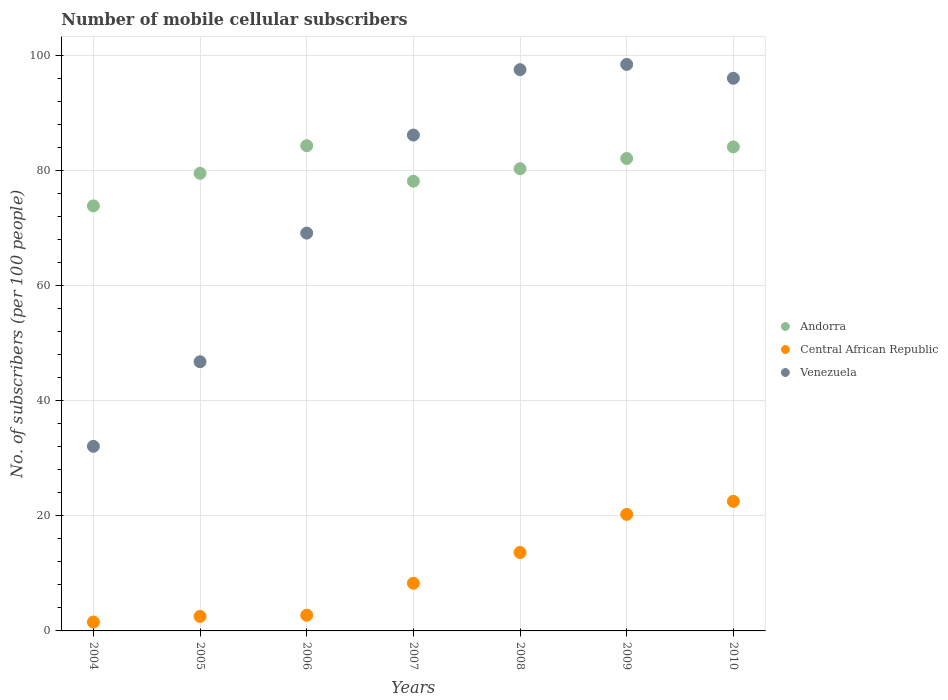How many different coloured dotlines are there?
Offer a very short reply. 3. Is the number of dotlines equal to the number of legend labels?
Your answer should be compact. Yes. What is the number of mobile cellular subscribers in Venezuela in 2010?
Provide a succinct answer. 96. Across all years, what is the maximum number of mobile cellular subscribers in Venezuela?
Make the answer very short. 98.39. Across all years, what is the minimum number of mobile cellular subscribers in Venezuela?
Ensure brevity in your answer.  32.07. In which year was the number of mobile cellular subscribers in Venezuela minimum?
Provide a short and direct response. 2004. What is the total number of mobile cellular subscribers in Central African Republic in the graph?
Make the answer very short. 71.45. What is the difference between the number of mobile cellular subscribers in Andorra in 2004 and that in 2010?
Provide a succinct answer. -10.24. What is the difference between the number of mobile cellular subscribers in Central African Republic in 2004 and the number of mobile cellular subscribers in Andorra in 2005?
Your answer should be very brief. -77.94. What is the average number of mobile cellular subscribers in Central African Republic per year?
Keep it short and to the point. 10.21. In the year 2007, what is the difference between the number of mobile cellular subscribers in Venezuela and number of mobile cellular subscribers in Central African Republic?
Your answer should be compact. 77.85. What is the ratio of the number of mobile cellular subscribers in Venezuela in 2005 to that in 2006?
Provide a succinct answer. 0.68. What is the difference between the highest and the second highest number of mobile cellular subscribers in Venezuela?
Keep it short and to the point. 0.9. What is the difference between the highest and the lowest number of mobile cellular subscribers in Andorra?
Offer a terse response. 10.45. Is it the case that in every year, the sum of the number of mobile cellular subscribers in Venezuela and number of mobile cellular subscribers in Central African Republic  is greater than the number of mobile cellular subscribers in Andorra?
Give a very brief answer. No. Does the number of mobile cellular subscribers in Venezuela monotonically increase over the years?
Offer a terse response. No. Is the number of mobile cellular subscribers in Central African Republic strictly greater than the number of mobile cellular subscribers in Venezuela over the years?
Offer a terse response. No. Is the number of mobile cellular subscribers in Central African Republic strictly less than the number of mobile cellular subscribers in Andorra over the years?
Make the answer very short. Yes. Are the values on the major ticks of Y-axis written in scientific E-notation?
Ensure brevity in your answer.  No. Does the graph contain any zero values?
Make the answer very short. No. Does the graph contain grids?
Offer a very short reply. Yes. Where does the legend appear in the graph?
Your response must be concise. Center right. How are the legend labels stacked?
Your answer should be compact. Vertical. What is the title of the graph?
Your response must be concise. Number of mobile cellular subscribers. Does "Romania" appear as one of the legend labels in the graph?
Give a very brief answer. No. What is the label or title of the Y-axis?
Keep it short and to the point. No. of subscribers (per 100 people). What is the No. of subscribers (per 100 people) of Andorra in 2004?
Your response must be concise. 73.82. What is the No. of subscribers (per 100 people) of Central African Republic in 2004?
Your answer should be very brief. 1.54. What is the No. of subscribers (per 100 people) in Venezuela in 2004?
Your answer should be compact. 32.07. What is the No. of subscribers (per 100 people) in Andorra in 2005?
Your answer should be compact. 79.48. What is the No. of subscribers (per 100 people) of Central African Republic in 2005?
Your response must be concise. 2.52. What is the No. of subscribers (per 100 people) of Venezuela in 2005?
Give a very brief answer. 46.76. What is the No. of subscribers (per 100 people) in Andorra in 2006?
Offer a terse response. 84.28. What is the No. of subscribers (per 100 people) in Central African Republic in 2006?
Offer a terse response. 2.73. What is the No. of subscribers (per 100 people) of Venezuela in 2006?
Keep it short and to the point. 69.1. What is the No. of subscribers (per 100 people) in Andorra in 2007?
Your answer should be compact. 78.12. What is the No. of subscribers (per 100 people) in Central African Republic in 2007?
Keep it short and to the point. 8.28. What is the No. of subscribers (per 100 people) of Venezuela in 2007?
Give a very brief answer. 86.13. What is the No. of subscribers (per 100 people) in Andorra in 2008?
Offer a terse response. 80.28. What is the No. of subscribers (per 100 people) in Central African Republic in 2008?
Your answer should be very brief. 13.62. What is the No. of subscribers (per 100 people) of Venezuela in 2008?
Offer a very short reply. 97.49. What is the No. of subscribers (per 100 people) in Andorra in 2009?
Make the answer very short. 82.06. What is the No. of subscribers (per 100 people) of Central African Republic in 2009?
Ensure brevity in your answer.  20.24. What is the No. of subscribers (per 100 people) of Venezuela in 2009?
Your answer should be very brief. 98.39. What is the No. of subscribers (per 100 people) in Andorra in 2010?
Offer a terse response. 84.07. What is the No. of subscribers (per 100 people) in Central African Republic in 2010?
Your response must be concise. 22.51. What is the No. of subscribers (per 100 people) of Venezuela in 2010?
Provide a succinct answer. 96. Across all years, what is the maximum No. of subscribers (per 100 people) of Andorra?
Ensure brevity in your answer.  84.28. Across all years, what is the maximum No. of subscribers (per 100 people) of Central African Republic?
Offer a terse response. 22.51. Across all years, what is the maximum No. of subscribers (per 100 people) of Venezuela?
Make the answer very short. 98.39. Across all years, what is the minimum No. of subscribers (per 100 people) of Andorra?
Your response must be concise. 73.82. Across all years, what is the minimum No. of subscribers (per 100 people) of Central African Republic?
Provide a short and direct response. 1.54. Across all years, what is the minimum No. of subscribers (per 100 people) in Venezuela?
Give a very brief answer. 32.07. What is the total No. of subscribers (per 100 people) in Andorra in the graph?
Your response must be concise. 562.12. What is the total No. of subscribers (per 100 people) of Central African Republic in the graph?
Your response must be concise. 71.45. What is the total No. of subscribers (per 100 people) in Venezuela in the graph?
Ensure brevity in your answer.  525.93. What is the difference between the No. of subscribers (per 100 people) of Andorra in 2004 and that in 2005?
Provide a succinct answer. -5.66. What is the difference between the No. of subscribers (per 100 people) in Central African Republic in 2004 and that in 2005?
Offer a terse response. -0.98. What is the difference between the No. of subscribers (per 100 people) in Venezuela in 2004 and that in 2005?
Offer a terse response. -14.69. What is the difference between the No. of subscribers (per 100 people) in Andorra in 2004 and that in 2006?
Provide a succinct answer. -10.45. What is the difference between the No. of subscribers (per 100 people) of Central African Republic in 2004 and that in 2006?
Offer a very short reply. -1.19. What is the difference between the No. of subscribers (per 100 people) in Venezuela in 2004 and that in 2006?
Offer a terse response. -37.04. What is the difference between the No. of subscribers (per 100 people) in Andorra in 2004 and that in 2007?
Provide a succinct answer. -4.29. What is the difference between the No. of subscribers (per 100 people) in Central African Republic in 2004 and that in 2007?
Keep it short and to the point. -6.74. What is the difference between the No. of subscribers (per 100 people) in Venezuela in 2004 and that in 2007?
Provide a short and direct response. -54.06. What is the difference between the No. of subscribers (per 100 people) of Andorra in 2004 and that in 2008?
Make the answer very short. -6.46. What is the difference between the No. of subscribers (per 100 people) of Central African Republic in 2004 and that in 2008?
Your answer should be compact. -12.08. What is the difference between the No. of subscribers (per 100 people) of Venezuela in 2004 and that in 2008?
Your response must be concise. -65.42. What is the difference between the No. of subscribers (per 100 people) of Andorra in 2004 and that in 2009?
Keep it short and to the point. -8.24. What is the difference between the No. of subscribers (per 100 people) of Central African Republic in 2004 and that in 2009?
Ensure brevity in your answer.  -18.7. What is the difference between the No. of subscribers (per 100 people) in Venezuela in 2004 and that in 2009?
Make the answer very short. -66.33. What is the difference between the No. of subscribers (per 100 people) of Andorra in 2004 and that in 2010?
Ensure brevity in your answer.  -10.24. What is the difference between the No. of subscribers (per 100 people) in Central African Republic in 2004 and that in 2010?
Provide a short and direct response. -20.97. What is the difference between the No. of subscribers (per 100 people) in Venezuela in 2004 and that in 2010?
Offer a terse response. -63.93. What is the difference between the No. of subscribers (per 100 people) in Andorra in 2005 and that in 2006?
Your response must be concise. -4.79. What is the difference between the No. of subscribers (per 100 people) of Central African Republic in 2005 and that in 2006?
Keep it short and to the point. -0.2. What is the difference between the No. of subscribers (per 100 people) of Venezuela in 2005 and that in 2006?
Give a very brief answer. -22.35. What is the difference between the No. of subscribers (per 100 people) in Andorra in 2005 and that in 2007?
Give a very brief answer. 1.37. What is the difference between the No. of subscribers (per 100 people) of Central African Republic in 2005 and that in 2007?
Provide a short and direct response. -5.75. What is the difference between the No. of subscribers (per 100 people) of Venezuela in 2005 and that in 2007?
Your answer should be very brief. -39.38. What is the difference between the No. of subscribers (per 100 people) in Andorra in 2005 and that in 2008?
Provide a short and direct response. -0.8. What is the difference between the No. of subscribers (per 100 people) of Central African Republic in 2005 and that in 2008?
Keep it short and to the point. -11.1. What is the difference between the No. of subscribers (per 100 people) of Venezuela in 2005 and that in 2008?
Your answer should be compact. -50.73. What is the difference between the No. of subscribers (per 100 people) in Andorra in 2005 and that in 2009?
Provide a succinct answer. -2.58. What is the difference between the No. of subscribers (per 100 people) in Central African Republic in 2005 and that in 2009?
Provide a short and direct response. -17.72. What is the difference between the No. of subscribers (per 100 people) in Venezuela in 2005 and that in 2009?
Make the answer very short. -51.64. What is the difference between the No. of subscribers (per 100 people) of Andorra in 2005 and that in 2010?
Keep it short and to the point. -4.58. What is the difference between the No. of subscribers (per 100 people) in Central African Republic in 2005 and that in 2010?
Your response must be concise. -19.99. What is the difference between the No. of subscribers (per 100 people) in Venezuela in 2005 and that in 2010?
Offer a very short reply. -49.24. What is the difference between the No. of subscribers (per 100 people) of Andorra in 2006 and that in 2007?
Your answer should be compact. 6.16. What is the difference between the No. of subscribers (per 100 people) of Central African Republic in 2006 and that in 2007?
Offer a very short reply. -5.55. What is the difference between the No. of subscribers (per 100 people) in Venezuela in 2006 and that in 2007?
Offer a terse response. -17.03. What is the difference between the No. of subscribers (per 100 people) in Andorra in 2006 and that in 2008?
Ensure brevity in your answer.  3.99. What is the difference between the No. of subscribers (per 100 people) of Central African Republic in 2006 and that in 2008?
Make the answer very short. -10.89. What is the difference between the No. of subscribers (per 100 people) of Venezuela in 2006 and that in 2008?
Your response must be concise. -28.39. What is the difference between the No. of subscribers (per 100 people) of Andorra in 2006 and that in 2009?
Your answer should be very brief. 2.22. What is the difference between the No. of subscribers (per 100 people) in Central African Republic in 2006 and that in 2009?
Make the answer very short. -17.52. What is the difference between the No. of subscribers (per 100 people) of Venezuela in 2006 and that in 2009?
Ensure brevity in your answer.  -29.29. What is the difference between the No. of subscribers (per 100 people) in Andorra in 2006 and that in 2010?
Keep it short and to the point. 0.21. What is the difference between the No. of subscribers (per 100 people) in Central African Republic in 2006 and that in 2010?
Give a very brief answer. -19.78. What is the difference between the No. of subscribers (per 100 people) of Venezuela in 2006 and that in 2010?
Keep it short and to the point. -26.89. What is the difference between the No. of subscribers (per 100 people) in Andorra in 2007 and that in 2008?
Your response must be concise. -2.17. What is the difference between the No. of subscribers (per 100 people) in Central African Republic in 2007 and that in 2008?
Give a very brief answer. -5.34. What is the difference between the No. of subscribers (per 100 people) of Venezuela in 2007 and that in 2008?
Provide a short and direct response. -11.36. What is the difference between the No. of subscribers (per 100 people) in Andorra in 2007 and that in 2009?
Keep it short and to the point. -3.94. What is the difference between the No. of subscribers (per 100 people) in Central African Republic in 2007 and that in 2009?
Provide a short and direct response. -11.96. What is the difference between the No. of subscribers (per 100 people) in Venezuela in 2007 and that in 2009?
Make the answer very short. -12.26. What is the difference between the No. of subscribers (per 100 people) in Andorra in 2007 and that in 2010?
Your answer should be very brief. -5.95. What is the difference between the No. of subscribers (per 100 people) in Central African Republic in 2007 and that in 2010?
Offer a terse response. -14.23. What is the difference between the No. of subscribers (per 100 people) of Venezuela in 2007 and that in 2010?
Your answer should be compact. -9.86. What is the difference between the No. of subscribers (per 100 people) in Andorra in 2008 and that in 2009?
Provide a short and direct response. -1.78. What is the difference between the No. of subscribers (per 100 people) of Central African Republic in 2008 and that in 2009?
Offer a very short reply. -6.62. What is the difference between the No. of subscribers (per 100 people) of Venezuela in 2008 and that in 2009?
Give a very brief answer. -0.9. What is the difference between the No. of subscribers (per 100 people) of Andorra in 2008 and that in 2010?
Provide a short and direct response. -3.78. What is the difference between the No. of subscribers (per 100 people) of Central African Republic in 2008 and that in 2010?
Your answer should be compact. -8.89. What is the difference between the No. of subscribers (per 100 people) of Venezuela in 2008 and that in 2010?
Offer a terse response. 1.49. What is the difference between the No. of subscribers (per 100 people) in Andorra in 2009 and that in 2010?
Offer a very short reply. -2.01. What is the difference between the No. of subscribers (per 100 people) of Central African Republic in 2009 and that in 2010?
Your answer should be compact. -2.27. What is the difference between the No. of subscribers (per 100 people) of Venezuela in 2009 and that in 2010?
Make the answer very short. 2.4. What is the difference between the No. of subscribers (per 100 people) of Andorra in 2004 and the No. of subscribers (per 100 people) of Central African Republic in 2005?
Offer a very short reply. 71.3. What is the difference between the No. of subscribers (per 100 people) of Andorra in 2004 and the No. of subscribers (per 100 people) of Venezuela in 2005?
Your answer should be compact. 27.07. What is the difference between the No. of subscribers (per 100 people) of Central African Republic in 2004 and the No. of subscribers (per 100 people) of Venezuela in 2005?
Ensure brevity in your answer.  -45.21. What is the difference between the No. of subscribers (per 100 people) of Andorra in 2004 and the No. of subscribers (per 100 people) of Central African Republic in 2006?
Give a very brief answer. 71.1. What is the difference between the No. of subscribers (per 100 people) in Andorra in 2004 and the No. of subscribers (per 100 people) in Venezuela in 2006?
Ensure brevity in your answer.  4.72. What is the difference between the No. of subscribers (per 100 people) in Central African Republic in 2004 and the No. of subscribers (per 100 people) in Venezuela in 2006?
Ensure brevity in your answer.  -67.56. What is the difference between the No. of subscribers (per 100 people) of Andorra in 2004 and the No. of subscribers (per 100 people) of Central African Republic in 2007?
Give a very brief answer. 65.55. What is the difference between the No. of subscribers (per 100 people) in Andorra in 2004 and the No. of subscribers (per 100 people) in Venezuela in 2007?
Provide a succinct answer. -12.31. What is the difference between the No. of subscribers (per 100 people) of Central African Republic in 2004 and the No. of subscribers (per 100 people) of Venezuela in 2007?
Offer a terse response. -84.59. What is the difference between the No. of subscribers (per 100 people) in Andorra in 2004 and the No. of subscribers (per 100 people) in Central African Republic in 2008?
Offer a very short reply. 60.21. What is the difference between the No. of subscribers (per 100 people) of Andorra in 2004 and the No. of subscribers (per 100 people) of Venezuela in 2008?
Make the answer very short. -23.66. What is the difference between the No. of subscribers (per 100 people) of Central African Republic in 2004 and the No. of subscribers (per 100 people) of Venezuela in 2008?
Give a very brief answer. -95.95. What is the difference between the No. of subscribers (per 100 people) in Andorra in 2004 and the No. of subscribers (per 100 people) in Central African Republic in 2009?
Make the answer very short. 53.58. What is the difference between the No. of subscribers (per 100 people) in Andorra in 2004 and the No. of subscribers (per 100 people) in Venezuela in 2009?
Offer a terse response. -24.57. What is the difference between the No. of subscribers (per 100 people) of Central African Republic in 2004 and the No. of subscribers (per 100 people) of Venezuela in 2009?
Make the answer very short. -96.85. What is the difference between the No. of subscribers (per 100 people) of Andorra in 2004 and the No. of subscribers (per 100 people) of Central African Republic in 2010?
Make the answer very short. 51.31. What is the difference between the No. of subscribers (per 100 people) of Andorra in 2004 and the No. of subscribers (per 100 people) of Venezuela in 2010?
Keep it short and to the point. -22.17. What is the difference between the No. of subscribers (per 100 people) of Central African Republic in 2004 and the No. of subscribers (per 100 people) of Venezuela in 2010?
Make the answer very short. -94.45. What is the difference between the No. of subscribers (per 100 people) in Andorra in 2005 and the No. of subscribers (per 100 people) in Central African Republic in 2006?
Make the answer very short. 76.76. What is the difference between the No. of subscribers (per 100 people) of Andorra in 2005 and the No. of subscribers (per 100 people) of Venezuela in 2006?
Provide a short and direct response. 10.38. What is the difference between the No. of subscribers (per 100 people) in Central African Republic in 2005 and the No. of subscribers (per 100 people) in Venezuela in 2006?
Offer a very short reply. -66.58. What is the difference between the No. of subscribers (per 100 people) in Andorra in 2005 and the No. of subscribers (per 100 people) in Central African Republic in 2007?
Make the answer very short. 71.21. What is the difference between the No. of subscribers (per 100 people) of Andorra in 2005 and the No. of subscribers (per 100 people) of Venezuela in 2007?
Ensure brevity in your answer.  -6.65. What is the difference between the No. of subscribers (per 100 people) of Central African Republic in 2005 and the No. of subscribers (per 100 people) of Venezuela in 2007?
Your answer should be compact. -83.61. What is the difference between the No. of subscribers (per 100 people) of Andorra in 2005 and the No. of subscribers (per 100 people) of Central African Republic in 2008?
Offer a very short reply. 65.87. What is the difference between the No. of subscribers (per 100 people) of Andorra in 2005 and the No. of subscribers (per 100 people) of Venezuela in 2008?
Your response must be concise. -18. What is the difference between the No. of subscribers (per 100 people) in Central African Republic in 2005 and the No. of subscribers (per 100 people) in Venezuela in 2008?
Your answer should be compact. -94.96. What is the difference between the No. of subscribers (per 100 people) of Andorra in 2005 and the No. of subscribers (per 100 people) of Central African Republic in 2009?
Make the answer very short. 59.24. What is the difference between the No. of subscribers (per 100 people) of Andorra in 2005 and the No. of subscribers (per 100 people) of Venezuela in 2009?
Give a very brief answer. -18.91. What is the difference between the No. of subscribers (per 100 people) of Central African Republic in 2005 and the No. of subscribers (per 100 people) of Venezuela in 2009?
Give a very brief answer. -95.87. What is the difference between the No. of subscribers (per 100 people) of Andorra in 2005 and the No. of subscribers (per 100 people) of Central African Republic in 2010?
Your answer should be compact. 56.97. What is the difference between the No. of subscribers (per 100 people) in Andorra in 2005 and the No. of subscribers (per 100 people) in Venezuela in 2010?
Provide a succinct answer. -16.51. What is the difference between the No. of subscribers (per 100 people) in Central African Republic in 2005 and the No. of subscribers (per 100 people) in Venezuela in 2010?
Offer a very short reply. -93.47. What is the difference between the No. of subscribers (per 100 people) of Andorra in 2006 and the No. of subscribers (per 100 people) of Central African Republic in 2007?
Provide a succinct answer. 76. What is the difference between the No. of subscribers (per 100 people) in Andorra in 2006 and the No. of subscribers (per 100 people) in Venezuela in 2007?
Ensure brevity in your answer.  -1.85. What is the difference between the No. of subscribers (per 100 people) of Central African Republic in 2006 and the No. of subscribers (per 100 people) of Venezuela in 2007?
Offer a very short reply. -83.4. What is the difference between the No. of subscribers (per 100 people) in Andorra in 2006 and the No. of subscribers (per 100 people) in Central African Republic in 2008?
Offer a very short reply. 70.66. What is the difference between the No. of subscribers (per 100 people) in Andorra in 2006 and the No. of subscribers (per 100 people) in Venezuela in 2008?
Give a very brief answer. -13.21. What is the difference between the No. of subscribers (per 100 people) in Central African Republic in 2006 and the No. of subscribers (per 100 people) in Venezuela in 2008?
Ensure brevity in your answer.  -94.76. What is the difference between the No. of subscribers (per 100 people) of Andorra in 2006 and the No. of subscribers (per 100 people) of Central African Republic in 2009?
Make the answer very short. 64.03. What is the difference between the No. of subscribers (per 100 people) of Andorra in 2006 and the No. of subscribers (per 100 people) of Venezuela in 2009?
Offer a very short reply. -14.11. What is the difference between the No. of subscribers (per 100 people) of Central African Republic in 2006 and the No. of subscribers (per 100 people) of Venezuela in 2009?
Ensure brevity in your answer.  -95.66. What is the difference between the No. of subscribers (per 100 people) of Andorra in 2006 and the No. of subscribers (per 100 people) of Central African Republic in 2010?
Your response must be concise. 61.77. What is the difference between the No. of subscribers (per 100 people) of Andorra in 2006 and the No. of subscribers (per 100 people) of Venezuela in 2010?
Your response must be concise. -11.72. What is the difference between the No. of subscribers (per 100 people) of Central African Republic in 2006 and the No. of subscribers (per 100 people) of Venezuela in 2010?
Your answer should be very brief. -93.27. What is the difference between the No. of subscribers (per 100 people) of Andorra in 2007 and the No. of subscribers (per 100 people) of Central African Republic in 2008?
Give a very brief answer. 64.5. What is the difference between the No. of subscribers (per 100 people) in Andorra in 2007 and the No. of subscribers (per 100 people) in Venezuela in 2008?
Give a very brief answer. -19.37. What is the difference between the No. of subscribers (per 100 people) in Central African Republic in 2007 and the No. of subscribers (per 100 people) in Venezuela in 2008?
Make the answer very short. -89.21. What is the difference between the No. of subscribers (per 100 people) of Andorra in 2007 and the No. of subscribers (per 100 people) of Central African Republic in 2009?
Your answer should be very brief. 57.87. What is the difference between the No. of subscribers (per 100 people) of Andorra in 2007 and the No. of subscribers (per 100 people) of Venezuela in 2009?
Offer a very short reply. -20.28. What is the difference between the No. of subscribers (per 100 people) in Central African Republic in 2007 and the No. of subscribers (per 100 people) in Venezuela in 2009?
Your answer should be very brief. -90.11. What is the difference between the No. of subscribers (per 100 people) in Andorra in 2007 and the No. of subscribers (per 100 people) in Central African Republic in 2010?
Make the answer very short. 55.61. What is the difference between the No. of subscribers (per 100 people) of Andorra in 2007 and the No. of subscribers (per 100 people) of Venezuela in 2010?
Provide a succinct answer. -17.88. What is the difference between the No. of subscribers (per 100 people) of Central African Republic in 2007 and the No. of subscribers (per 100 people) of Venezuela in 2010?
Your answer should be compact. -87.72. What is the difference between the No. of subscribers (per 100 people) in Andorra in 2008 and the No. of subscribers (per 100 people) in Central African Republic in 2009?
Ensure brevity in your answer.  60.04. What is the difference between the No. of subscribers (per 100 people) of Andorra in 2008 and the No. of subscribers (per 100 people) of Venezuela in 2009?
Your answer should be compact. -18.11. What is the difference between the No. of subscribers (per 100 people) in Central African Republic in 2008 and the No. of subscribers (per 100 people) in Venezuela in 2009?
Your response must be concise. -84.77. What is the difference between the No. of subscribers (per 100 people) in Andorra in 2008 and the No. of subscribers (per 100 people) in Central African Republic in 2010?
Your answer should be very brief. 57.77. What is the difference between the No. of subscribers (per 100 people) in Andorra in 2008 and the No. of subscribers (per 100 people) in Venezuela in 2010?
Your response must be concise. -15.71. What is the difference between the No. of subscribers (per 100 people) of Central African Republic in 2008 and the No. of subscribers (per 100 people) of Venezuela in 2010?
Provide a short and direct response. -82.38. What is the difference between the No. of subscribers (per 100 people) in Andorra in 2009 and the No. of subscribers (per 100 people) in Central African Republic in 2010?
Offer a very short reply. 59.55. What is the difference between the No. of subscribers (per 100 people) of Andorra in 2009 and the No. of subscribers (per 100 people) of Venezuela in 2010?
Give a very brief answer. -13.93. What is the difference between the No. of subscribers (per 100 people) of Central African Republic in 2009 and the No. of subscribers (per 100 people) of Venezuela in 2010?
Keep it short and to the point. -75.75. What is the average No. of subscribers (per 100 people) in Andorra per year?
Offer a terse response. 80.3. What is the average No. of subscribers (per 100 people) in Central African Republic per year?
Give a very brief answer. 10.21. What is the average No. of subscribers (per 100 people) of Venezuela per year?
Keep it short and to the point. 75.13. In the year 2004, what is the difference between the No. of subscribers (per 100 people) in Andorra and No. of subscribers (per 100 people) in Central African Republic?
Give a very brief answer. 72.28. In the year 2004, what is the difference between the No. of subscribers (per 100 people) in Andorra and No. of subscribers (per 100 people) in Venezuela?
Make the answer very short. 41.76. In the year 2004, what is the difference between the No. of subscribers (per 100 people) in Central African Republic and No. of subscribers (per 100 people) in Venezuela?
Provide a succinct answer. -30.53. In the year 2005, what is the difference between the No. of subscribers (per 100 people) of Andorra and No. of subscribers (per 100 people) of Central African Republic?
Your response must be concise. 76.96. In the year 2005, what is the difference between the No. of subscribers (per 100 people) in Andorra and No. of subscribers (per 100 people) in Venezuela?
Provide a succinct answer. 32.73. In the year 2005, what is the difference between the No. of subscribers (per 100 people) in Central African Republic and No. of subscribers (per 100 people) in Venezuela?
Provide a succinct answer. -44.23. In the year 2006, what is the difference between the No. of subscribers (per 100 people) in Andorra and No. of subscribers (per 100 people) in Central African Republic?
Provide a short and direct response. 81.55. In the year 2006, what is the difference between the No. of subscribers (per 100 people) in Andorra and No. of subscribers (per 100 people) in Venezuela?
Make the answer very short. 15.18. In the year 2006, what is the difference between the No. of subscribers (per 100 people) in Central African Republic and No. of subscribers (per 100 people) in Venezuela?
Offer a very short reply. -66.37. In the year 2007, what is the difference between the No. of subscribers (per 100 people) of Andorra and No. of subscribers (per 100 people) of Central African Republic?
Provide a short and direct response. 69.84. In the year 2007, what is the difference between the No. of subscribers (per 100 people) in Andorra and No. of subscribers (per 100 people) in Venezuela?
Ensure brevity in your answer.  -8.01. In the year 2007, what is the difference between the No. of subscribers (per 100 people) in Central African Republic and No. of subscribers (per 100 people) in Venezuela?
Make the answer very short. -77.85. In the year 2008, what is the difference between the No. of subscribers (per 100 people) of Andorra and No. of subscribers (per 100 people) of Central African Republic?
Your response must be concise. 66.66. In the year 2008, what is the difference between the No. of subscribers (per 100 people) in Andorra and No. of subscribers (per 100 people) in Venezuela?
Keep it short and to the point. -17.21. In the year 2008, what is the difference between the No. of subscribers (per 100 people) of Central African Republic and No. of subscribers (per 100 people) of Venezuela?
Your answer should be very brief. -83.87. In the year 2009, what is the difference between the No. of subscribers (per 100 people) in Andorra and No. of subscribers (per 100 people) in Central African Republic?
Offer a very short reply. 61.82. In the year 2009, what is the difference between the No. of subscribers (per 100 people) in Andorra and No. of subscribers (per 100 people) in Venezuela?
Your answer should be very brief. -16.33. In the year 2009, what is the difference between the No. of subscribers (per 100 people) in Central African Republic and No. of subscribers (per 100 people) in Venezuela?
Make the answer very short. -78.15. In the year 2010, what is the difference between the No. of subscribers (per 100 people) of Andorra and No. of subscribers (per 100 people) of Central African Republic?
Provide a succinct answer. 61.56. In the year 2010, what is the difference between the No. of subscribers (per 100 people) in Andorra and No. of subscribers (per 100 people) in Venezuela?
Your answer should be compact. -11.93. In the year 2010, what is the difference between the No. of subscribers (per 100 people) of Central African Republic and No. of subscribers (per 100 people) of Venezuela?
Provide a short and direct response. -73.48. What is the ratio of the No. of subscribers (per 100 people) of Andorra in 2004 to that in 2005?
Offer a terse response. 0.93. What is the ratio of the No. of subscribers (per 100 people) of Central African Republic in 2004 to that in 2005?
Your answer should be very brief. 0.61. What is the ratio of the No. of subscribers (per 100 people) in Venezuela in 2004 to that in 2005?
Give a very brief answer. 0.69. What is the ratio of the No. of subscribers (per 100 people) of Andorra in 2004 to that in 2006?
Your response must be concise. 0.88. What is the ratio of the No. of subscribers (per 100 people) of Central African Republic in 2004 to that in 2006?
Offer a terse response. 0.56. What is the ratio of the No. of subscribers (per 100 people) of Venezuela in 2004 to that in 2006?
Provide a succinct answer. 0.46. What is the ratio of the No. of subscribers (per 100 people) in Andorra in 2004 to that in 2007?
Make the answer very short. 0.95. What is the ratio of the No. of subscribers (per 100 people) of Central African Republic in 2004 to that in 2007?
Keep it short and to the point. 0.19. What is the ratio of the No. of subscribers (per 100 people) in Venezuela in 2004 to that in 2007?
Make the answer very short. 0.37. What is the ratio of the No. of subscribers (per 100 people) in Andorra in 2004 to that in 2008?
Keep it short and to the point. 0.92. What is the ratio of the No. of subscribers (per 100 people) in Central African Republic in 2004 to that in 2008?
Your answer should be compact. 0.11. What is the ratio of the No. of subscribers (per 100 people) in Venezuela in 2004 to that in 2008?
Provide a succinct answer. 0.33. What is the ratio of the No. of subscribers (per 100 people) in Andorra in 2004 to that in 2009?
Your answer should be very brief. 0.9. What is the ratio of the No. of subscribers (per 100 people) of Central African Republic in 2004 to that in 2009?
Ensure brevity in your answer.  0.08. What is the ratio of the No. of subscribers (per 100 people) in Venezuela in 2004 to that in 2009?
Provide a short and direct response. 0.33. What is the ratio of the No. of subscribers (per 100 people) of Andorra in 2004 to that in 2010?
Your response must be concise. 0.88. What is the ratio of the No. of subscribers (per 100 people) in Central African Republic in 2004 to that in 2010?
Provide a succinct answer. 0.07. What is the ratio of the No. of subscribers (per 100 people) in Venezuela in 2004 to that in 2010?
Give a very brief answer. 0.33. What is the ratio of the No. of subscribers (per 100 people) in Andorra in 2005 to that in 2006?
Ensure brevity in your answer.  0.94. What is the ratio of the No. of subscribers (per 100 people) in Central African Republic in 2005 to that in 2006?
Your answer should be very brief. 0.93. What is the ratio of the No. of subscribers (per 100 people) of Venezuela in 2005 to that in 2006?
Your answer should be very brief. 0.68. What is the ratio of the No. of subscribers (per 100 people) of Andorra in 2005 to that in 2007?
Your answer should be very brief. 1.02. What is the ratio of the No. of subscribers (per 100 people) in Central African Republic in 2005 to that in 2007?
Keep it short and to the point. 0.3. What is the ratio of the No. of subscribers (per 100 people) in Venezuela in 2005 to that in 2007?
Provide a succinct answer. 0.54. What is the ratio of the No. of subscribers (per 100 people) in Central African Republic in 2005 to that in 2008?
Ensure brevity in your answer.  0.19. What is the ratio of the No. of subscribers (per 100 people) of Venezuela in 2005 to that in 2008?
Your response must be concise. 0.48. What is the ratio of the No. of subscribers (per 100 people) in Andorra in 2005 to that in 2009?
Provide a succinct answer. 0.97. What is the ratio of the No. of subscribers (per 100 people) in Central African Republic in 2005 to that in 2009?
Provide a short and direct response. 0.12. What is the ratio of the No. of subscribers (per 100 people) of Venezuela in 2005 to that in 2009?
Offer a very short reply. 0.48. What is the ratio of the No. of subscribers (per 100 people) in Andorra in 2005 to that in 2010?
Offer a very short reply. 0.95. What is the ratio of the No. of subscribers (per 100 people) in Central African Republic in 2005 to that in 2010?
Your response must be concise. 0.11. What is the ratio of the No. of subscribers (per 100 people) in Venezuela in 2005 to that in 2010?
Give a very brief answer. 0.49. What is the ratio of the No. of subscribers (per 100 people) in Andorra in 2006 to that in 2007?
Give a very brief answer. 1.08. What is the ratio of the No. of subscribers (per 100 people) in Central African Republic in 2006 to that in 2007?
Your answer should be very brief. 0.33. What is the ratio of the No. of subscribers (per 100 people) of Venezuela in 2006 to that in 2007?
Make the answer very short. 0.8. What is the ratio of the No. of subscribers (per 100 people) in Andorra in 2006 to that in 2008?
Offer a very short reply. 1.05. What is the ratio of the No. of subscribers (per 100 people) in Central African Republic in 2006 to that in 2008?
Your answer should be compact. 0.2. What is the ratio of the No. of subscribers (per 100 people) of Venezuela in 2006 to that in 2008?
Provide a short and direct response. 0.71. What is the ratio of the No. of subscribers (per 100 people) of Andorra in 2006 to that in 2009?
Give a very brief answer. 1.03. What is the ratio of the No. of subscribers (per 100 people) of Central African Republic in 2006 to that in 2009?
Your answer should be compact. 0.13. What is the ratio of the No. of subscribers (per 100 people) in Venezuela in 2006 to that in 2009?
Make the answer very short. 0.7. What is the ratio of the No. of subscribers (per 100 people) in Andorra in 2006 to that in 2010?
Your response must be concise. 1. What is the ratio of the No. of subscribers (per 100 people) in Central African Republic in 2006 to that in 2010?
Ensure brevity in your answer.  0.12. What is the ratio of the No. of subscribers (per 100 people) in Venezuela in 2006 to that in 2010?
Your response must be concise. 0.72. What is the ratio of the No. of subscribers (per 100 people) of Central African Republic in 2007 to that in 2008?
Offer a very short reply. 0.61. What is the ratio of the No. of subscribers (per 100 people) in Venezuela in 2007 to that in 2008?
Offer a terse response. 0.88. What is the ratio of the No. of subscribers (per 100 people) in Andorra in 2007 to that in 2009?
Offer a very short reply. 0.95. What is the ratio of the No. of subscribers (per 100 people) of Central African Republic in 2007 to that in 2009?
Offer a terse response. 0.41. What is the ratio of the No. of subscribers (per 100 people) of Venezuela in 2007 to that in 2009?
Your answer should be compact. 0.88. What is the ratio of the No. of subscribers (per 100 people) in Andorra in 2007 to that in 2010?
Make the answer very short. 0.93. What is the ratio of the No. of subscribers (per 100 people) of Central African Republic in 2007 to that in 2010?
Your response must be concise. 0.37. What is the ratio of the No. of subscribers (per 100 people) in Venezuela in 2007 to that in 2010?
Offer a terse response. 0.9. What is the ratio of the No. of subscribers (per 100 people) in Andorra in 2008 to that in 2009?
Keep it short and to the point. 0.98. What is the ratio of the No. of subscribers (per 100 people) in Central African Republic in 2008 to that in 2009?
Ensure brevity in your answer.  0.67. What is the ratio of the No. of subscribers (per 100 people) of Venezuela in 2008 to that in 2009?
Ensure brevity in your answer.  0.99. What is the ratio of the No. of subscribers (per 100 people) in Andorra in 2008 to that in 2010?
Your answer should be compact. 0.95. What is the ratio of the No. of subscribers (per 100 people) of Central African Republic in 2008 to that in 2010?
Offer a terse response. 0.6. What is the ratio of the No. of subscribers (per 100 people) of Venezuela in 2008 to that in 2010?
Provide a succinct answer. 1.02. What is the ratio of the No. of subscribers (per 100 people) of Andorra in 2009 to that in 2010?
Your answer should be very brief. 0.98. What is the ratio of the No. of subscribers (per 100 people) in Central African Republic in 2009 to that in 2010?
Your answer should be very brief. 0.9. What is the ratio of the No. of subscribers (per 100 people) of Venezuela in 2009 to that in 2010?
Provide a short and direct response. 1.02. What is the difference between the highest and the second highest No. of subscribers (per 100 people) of Andorra?
Your response must be concise. 0.21. What is the difference between the highest and the second highest No. of subscribers (per 100 people) in Central African Republic?
Offer a very short reply. 2.27. What is the difference between the highest and the second highest No. of subscribers (per 100 people) in Venezuela?
Provide a succinct answer. 0.9. What is the difference between the highest and the lowest No. of subscribers (per 100 people) in Andorra?
Make the answer very short. 10.45. What is the difference between the highest and the lowest No. of subscribers (per 100 people) of Central African Republic?
Your answer should be very brief. 20.97. What is the difference between the highest and the lowest No. of subscribers (per 100 people) in Venezuela?
Offer a very short reply. 66.33. 